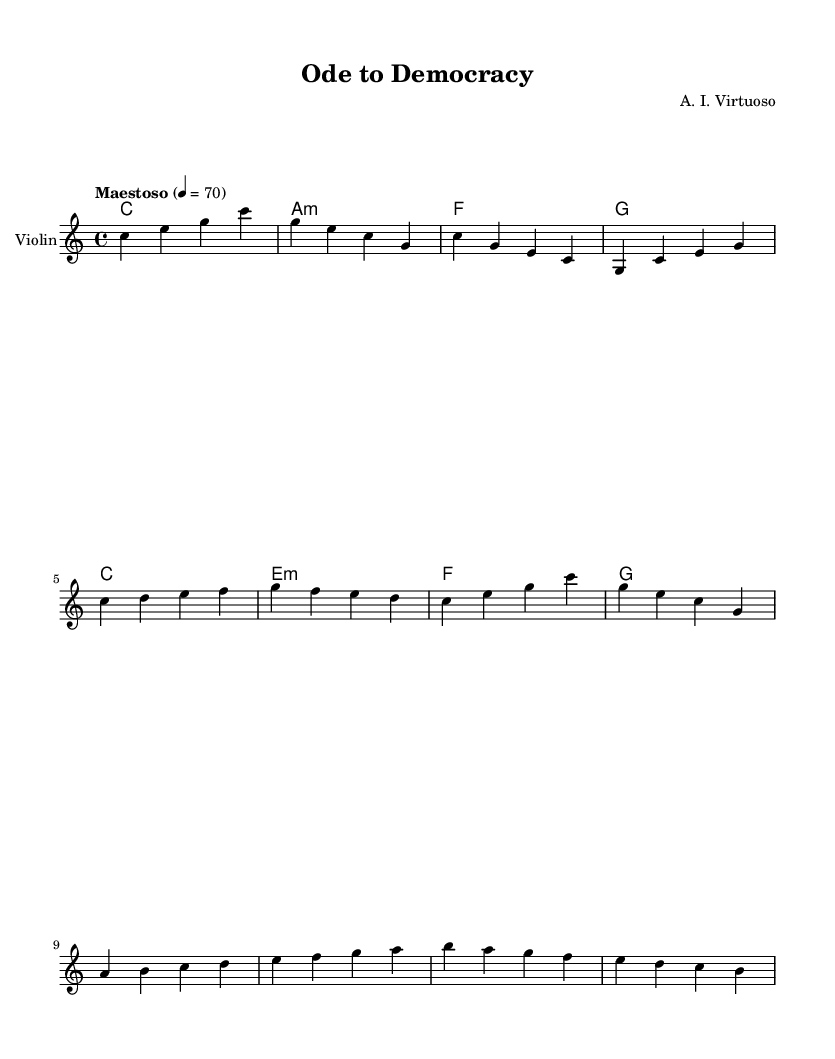What is the key signature of this music? The key signature is C major, which has no sharps or flats.
Answer: C major What is the time signature of this piece? The time signature is indicated at the beginning as 4/4, meaning there are four beats in each measure.
Answer: 4/4 What is the tempo marking of the composition? The tempo marking is "Maestoso", and it is set to 4 beats per minute at a speed of 70.
Answer: Maestoso How many measures are in the "Introduction"? The "Introduction" section consists of 4 measures, as indicated by the grouping of the music notes before the themes begin.
Answer: 4 What is the first note of Theme A? The first note of Theme A is C, which is the note that starts the melodic phrase of that theme.
Answer: C Which chord follows the A minor chord in the harmony? The chord that follows the A minor chord is F major, as shown in the chord progression after the A minor.
Answer: F How many distinct themes are presented in this composition? There are two distinct themes presented: Theme A and Theme B, as indicated by the structure of the sheet music.
Answer: 2 